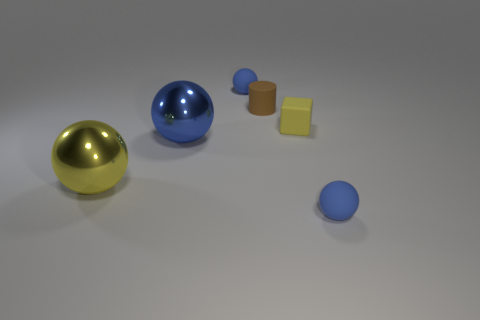There is a tiny ball that is in front of the blue shiny sphere left of the brown thing; what number of metallic objects are behind it? Behind the blue shiny sphere, there are two metallic objects visible. One is a gold-colored sphere, and the other appears to be a silver metallic cylinder. 